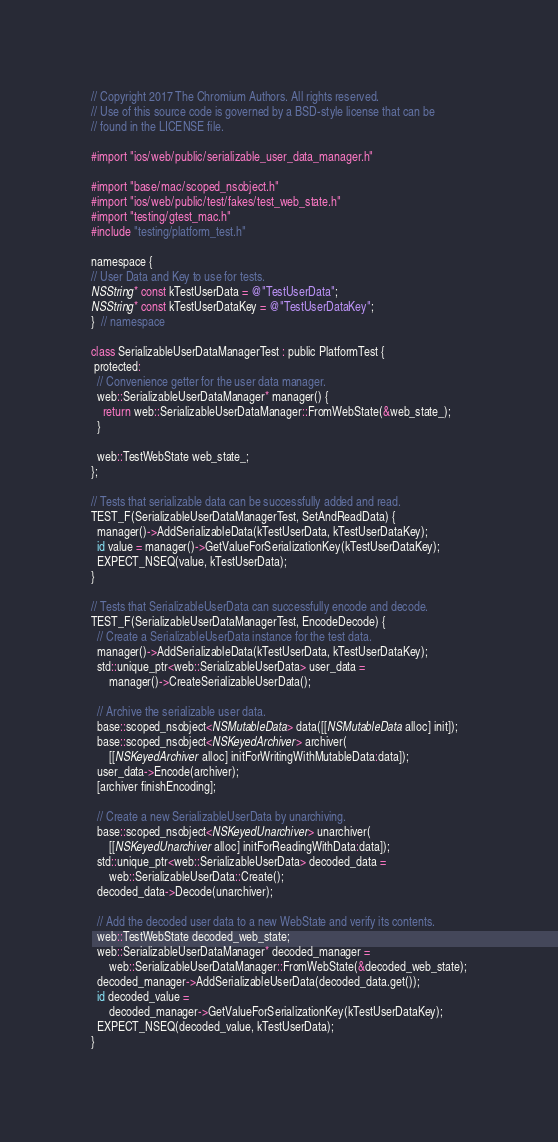<code> <loc_0><loc_0><loc_500><loc_500><_ObjectiveC_>// Copyright 2017 The Chromium Authors. All rights reserved.
// Use of this source code is governed by a BSD-style license that can be
// found in the LICENSE file.

#import "ios/web/public/serializable_user_data_manager.h"

#import "base/mac/scoped_nsobject.h"
#import "ios/web/public/test/fakes/test_web_state.h"
#import "testing/gtest_mac.h"
#include "testing/platform_test.h"

namespace {
// User Data and Key to use for tests.
NSString* const kTestUserData = @"TestUserData";
NSString* const kTestUserDataKey = @"TestUserDataKey";
}  // namespace

class SerializableUserDataManagerTest : public PlatformTest {
 protected:
  // Convenience getter for the user data manager.
  web::SerializableUserDataManager* manager() {
    return web::SerializableUserDataManager::FromWebState(&web_state_);
  }

  web::TestWebState web_state_;
};

// Tests that serializable data can be successfully added and read.
TEST_F(SerializableUserDataManagerTest, SetAndReadData) {
  manager()->AddSerializableData(kTestUserData, kTestUserDataKey);
  id value = manager()->GetValueForSerializationKey(kTestUserDataKey);
  EXPECT_NSEQ(value, kTestUserData);
}

// Tests that SerializableUserData can successfully encode and decode.
TEST_F(SerializableUserDataManagerTest, EncodeDecode) {
  // Create a SerializableUserData instance for the test data.
  manager()->AddSerializableData(kTestUserData, kTestUserDataKey);
  std::unique_ptr<web::SerializableUserData> user_data =
      manager()->CreateSerializableUserData();

  // Archive the serializable user data.
  base::scoped_nsobject<NSMutableData> data([[NSMutableData alloc] init]);
  base::scoped_nsobject<NSKeyedArchiver> archiver(
      [[NSKeyedArchiver alloc] initForWritingWithMutableData:data]);
  user_data->Encode(archiver);
  [archiver finishEncoding];

  // Create a new SerializableUserData by unarchiving.
  base::scoped_nsobject<NSKeyedUnarchiver> unarchiver(
      [[NSKeyedUnarchiver alloc] initForReadingWithData:data]);
  std::unique_ptr<web::SerializableUserData> decoded_data =
      web::SerializableUserData::Create();
  decoded_data->Decode(unarchiver);

  // Add the decoded user data to a new WebState and verify its contents.
  web::TestWebState decoded_web_state;
  web::SerializableUserDataManager* decoded_manager =
      web::SerializableUserDataManager::FromWebState(&decoded_web_state);
  decoded_manager->AddSerializableUserData(decoded_data.get());
  id decoded_value =
      decoded_manager->GetValueForSerializationKey(kTestUserDataKey);
  EXPECT_NSEQ(decoded_value, kTestUserData);
}
</code> 